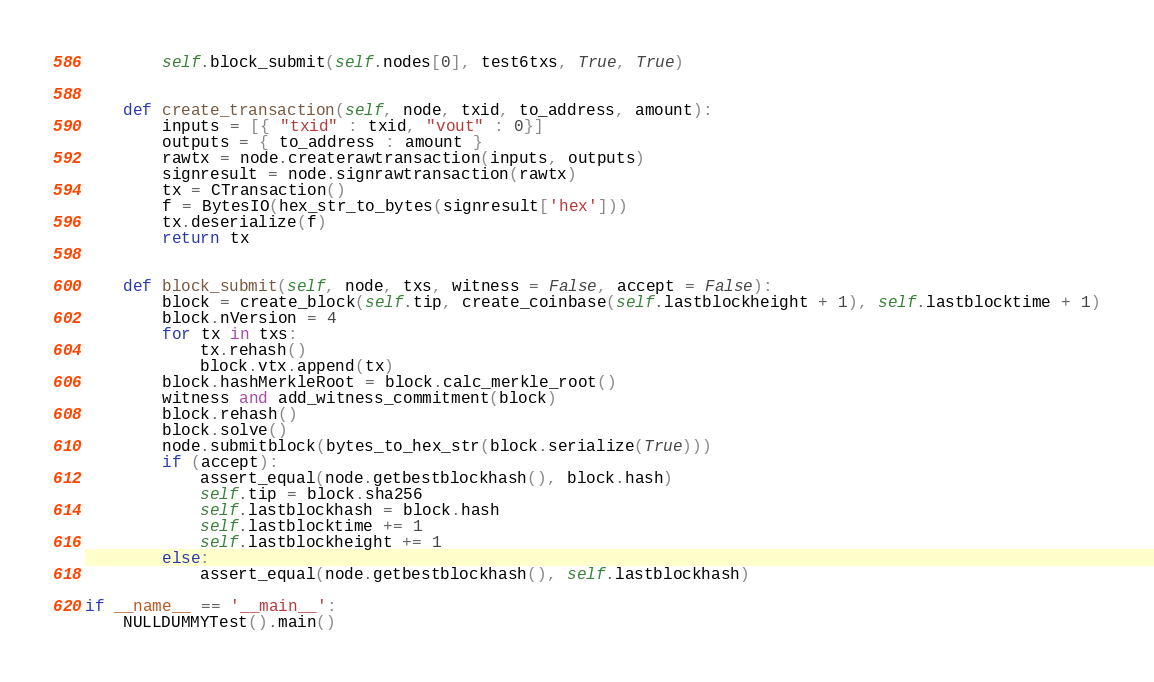Convert code to text. <code><loc_0><loc_0><loc_500><loc_500><_Python_>        self.block_submit(self.nodes[0], test6txs, True, True)


    def create_transaction(self, node, txid, to_address, amount):
        inputs = [{ "txid" : txid, "vout" : 0}]
        outputs = { to_address : amount }
        rawtx = node.createrawtransaction(inputs, outputs)
        signresult = node.signrawtransaction(rawtx)
        tx = CTransaction()
        f = BytesIO(hex_str_to_bytes(signresult['hex']))
        tx.deserialize(f)
        return tx


    def block_submit(self, node, txs, witness = False, accept = False):
        block = create_block(self.tip, create_coinbase(self.lastblockheight + 1), self.lastblocktime + 1)
        block.nVersion = 4
        for tx in txs:
            tx.rehash()
            block.vtx.append(tx)
        block.hashMerkleRoot = block.calc_merkle_root()
        witness and add_witness_commitment(block)
        block.rehash()
        block.solve()
        node.submitblock(bytes_to_hex_str(block.serialize(True)))
        if (accept):
            assert_equal(node.getbestblockhash(), block.hash)
            self.tip = block.sha256
            self.lastblockhash = block.hash
            self.lastblocktime += 1
            self.lastblockheight += 1
        else:
            assert_equal(node.getbestblockhash(), self.lastblockhash)

if __name__ == '__main__':
    NULLDUMMYTest().main()
</code> 